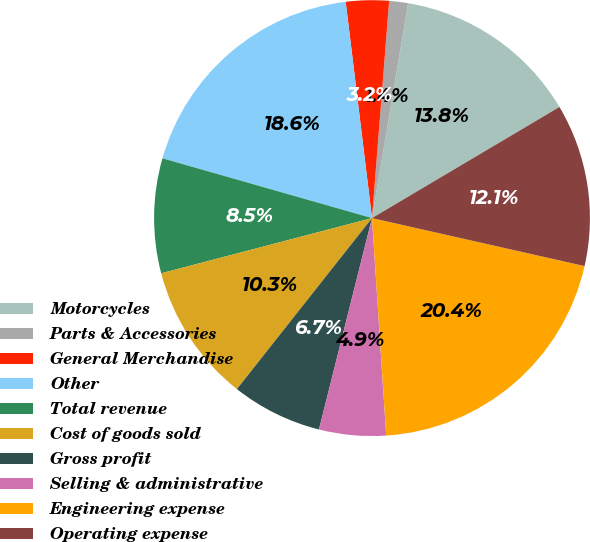<chart> <loc_0><loc_0><loc_500><loc_500><pie_chart><fcel>Motorcycles<fcel>Parts & Accessories<fcel>General Merchandise<fcel>Other<fcel>Total revenue<fcel>Cost of goods sold<fcel>Gross profit<fcel>Selling & administrative<fcel>Engineering expense<fcel>Operating expense<nl><fcel>13.83%<fcel>1.4%<fcel>3.18%<fcel>18.65%<fcel>8.5%<fcel>10.28%<fcel>6.73%<fcel>4.95%<fcel>20.43%<fcel>12.05%<nl></chart> 